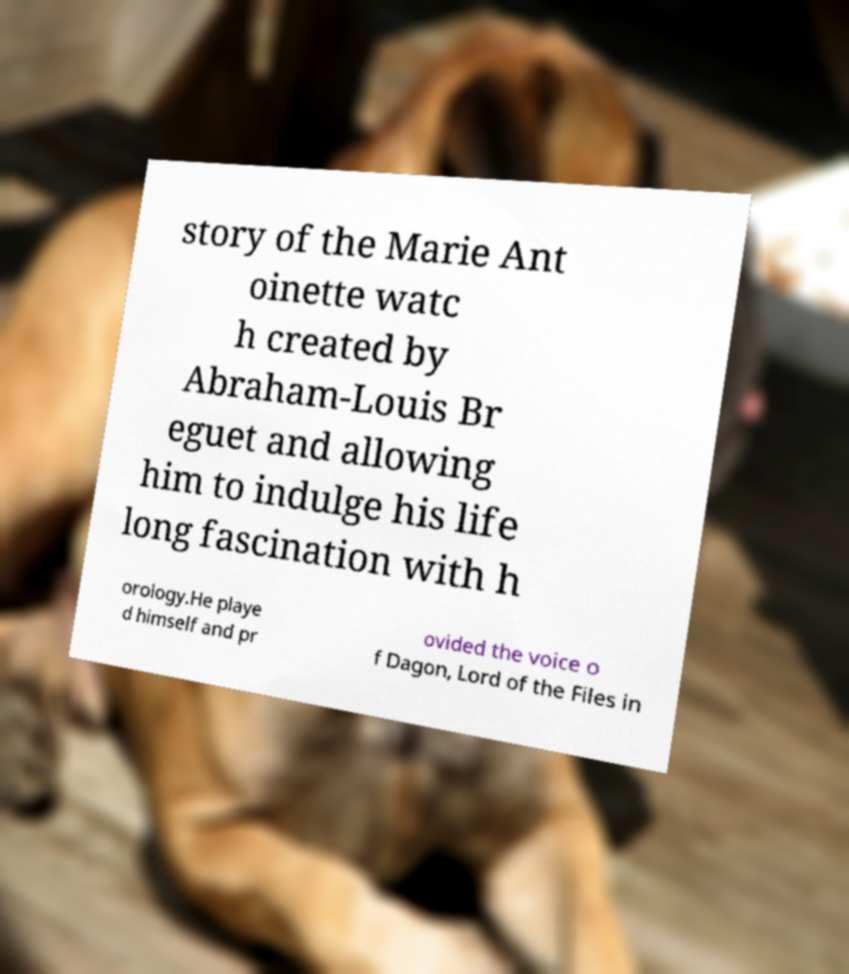Please read and relay the text visible in this image. What does it say? story of the Marie Ant oinette watc h created by Abraham-Louis Br eguet and allowing him to indulge his life long fascination with h orology.He playe d himself and pr ovided the voice o f Dagon, Lord of the Files in 